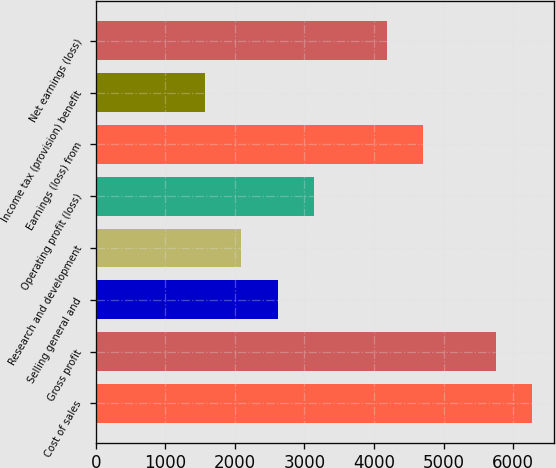Convert chart. <chart><loc_0><loc_0><loc_500><loc_500><bar_chart><fcel>Cost of sales<fcel>Gross profit<fcel>Selling general and<fcel>Research and development<fcel>Operating profit (loss)<fcel>Earnings (loss) from<fcel>Income tax (provision) benefit<fcel>Net earnings (loss)<nl><fcel>6270.43<fcel>5748.21<fcel>2614.89<fcel>2092.67<fcel>3137.11<fcel>4703.77<fcel>1570.45<fcel>4181.55<nl></chart> 